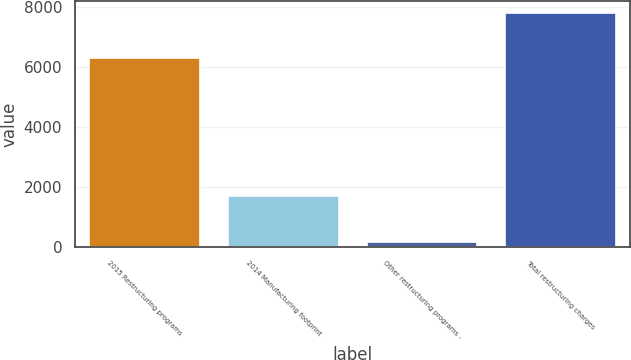<chart> <loc_0><loc_0><loc_500><loc_500><bar_chart><fcel>2015 Restructuring programs<fcel>2014 Manufacturing footprint<fcel>Other restructuring programs -<fcel>Total restructuring charges<nl><fcel>6304<fcel>1685<fcel>170<fcel>7819<nl></chart> 